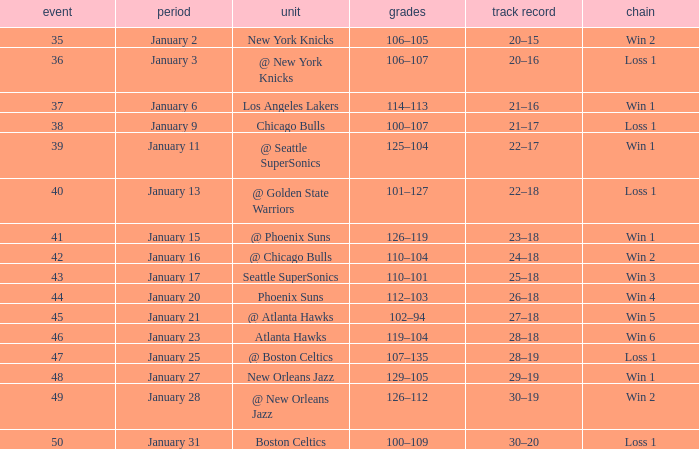What is the Team in Game 41? @ Phoenix Suns. 